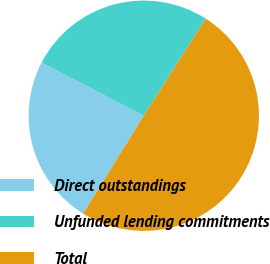Convert chart to OTSL. <chart><loc_0><loc_0><loc_500><loc_500><pie_chart><fcel>Direct outstandings<fcel>Unfunded lending commitments<fcel>Total<nl><fcel>23.81%<fcel>26.41%<fcel>49.78%<nl></chart> 